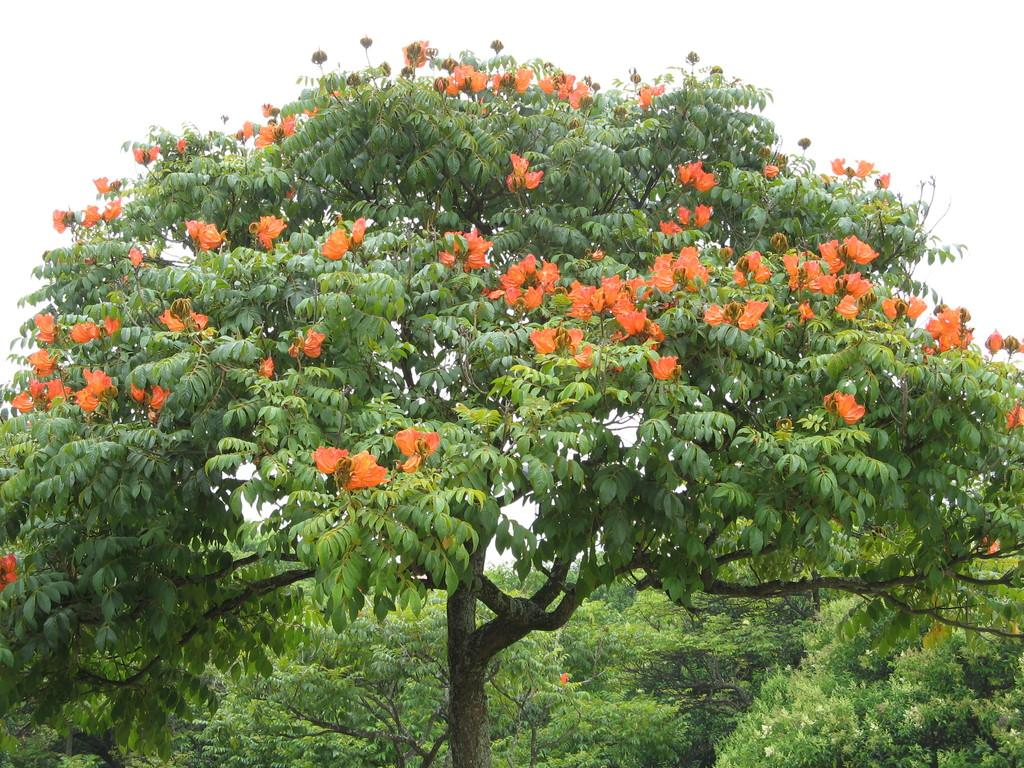What color are the flowers on the tree in the image? The flowers on the tree in the image are orange. What else can be seen in the image besides the tree with flowers? There are trees and the sky visible in the background of the image. What type of doctor can be seen treating a patient in the image? There is no doctor or patient present in the image; it features a tree with orange flowers and trees in the background. 